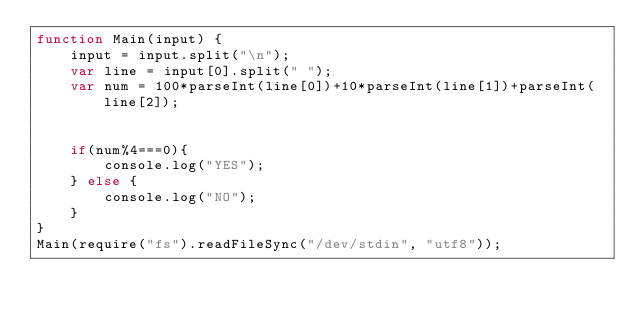Convert code to text. <code><loc_0><loc_0><loc_500><loc_500><_JavaScript_>function Main(input) {
    input = input.split("\n");
    var line = input[0].split(" ");
    var num = 100*parseInt(line[0])+10*parseInt(line[1])+parseInt(line[2]);
    

    if(num%4===0){
        console.log("YES");
    } else {
        console.log("NO");
    }
}
Main(require("fs").readFileSync("/dev/stdin", "utf8"));</code> 